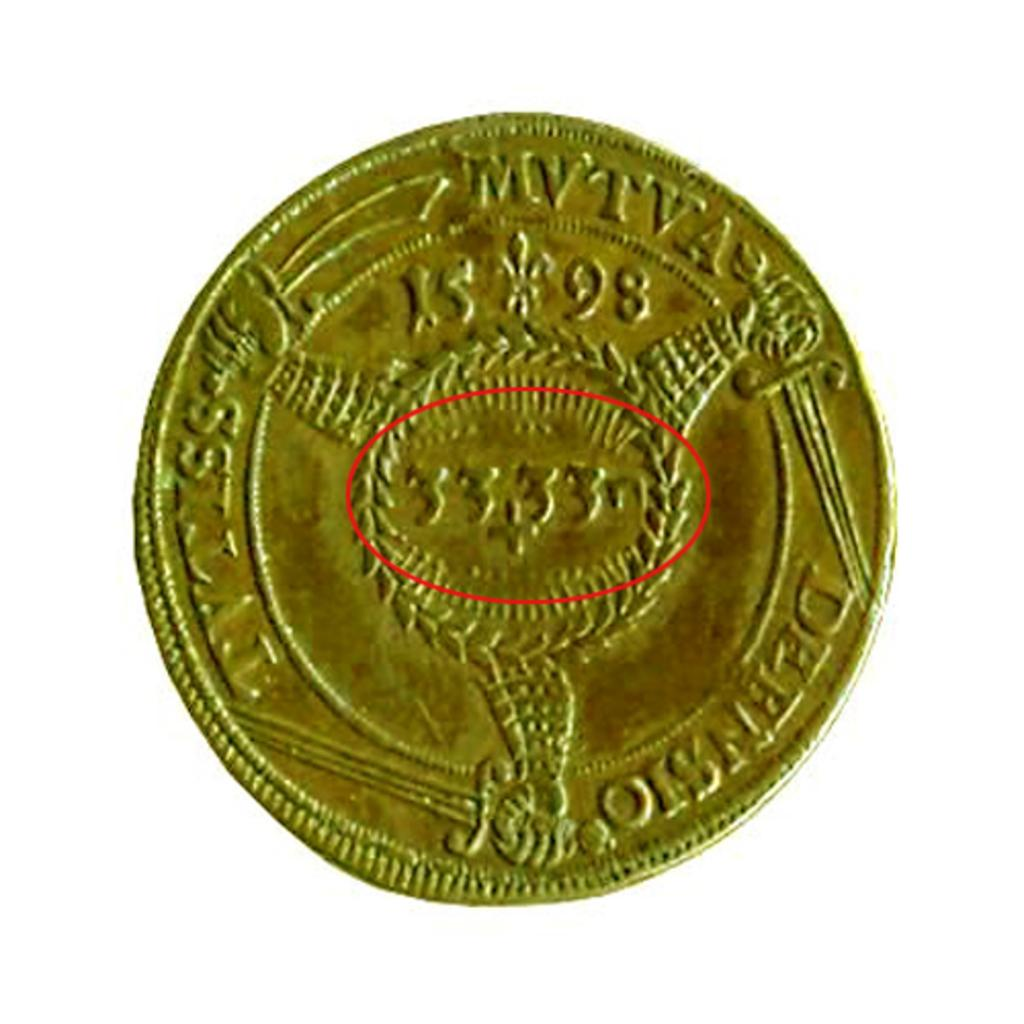<image>
Offer a succinct explanation of the picture presented. A gold coin has a red circle on it that notates the number 3333. 